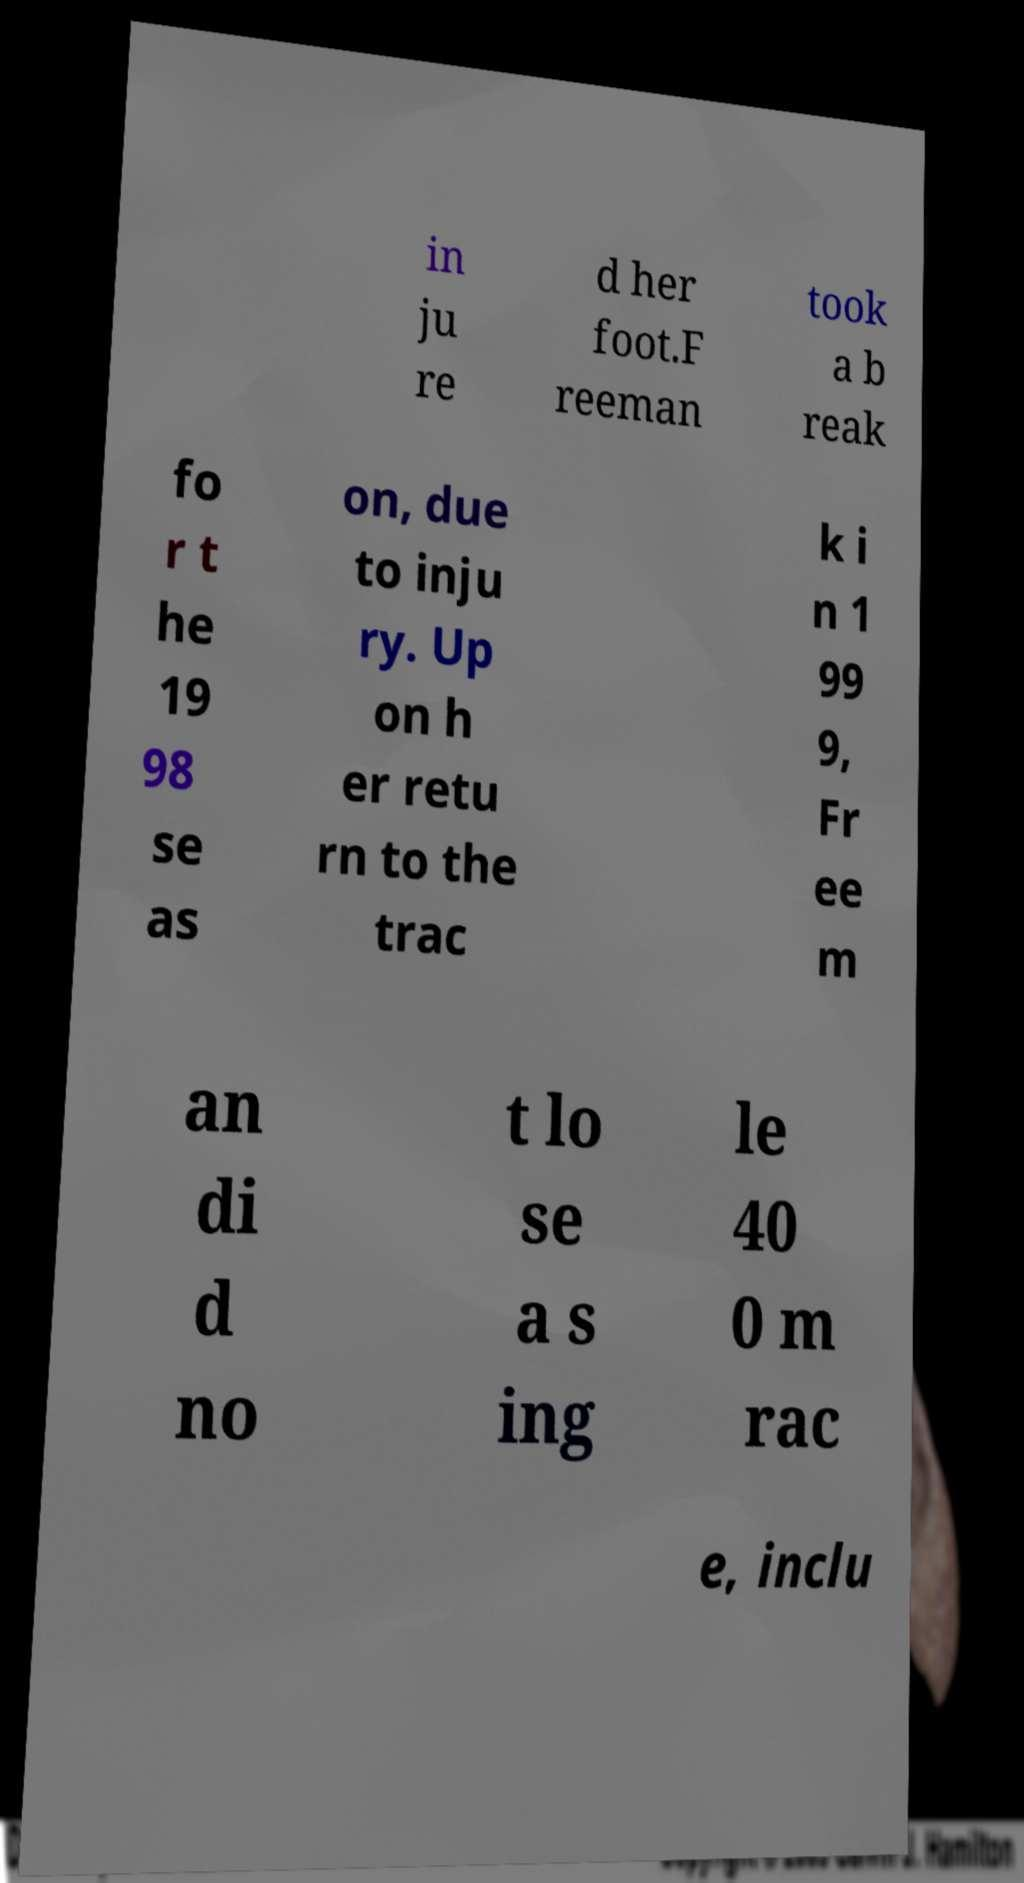Could you assist in decoding the text presented in this image and type it out clearly? in ju re d her foot.F reeman took a b reak fo r t he 19 98 se as on, due to inju ry. Up on h er retu rn to the trac k i n 1 99 9, Fr ee m an di d no t lo se a s ing le 40 0 m rac e, inclu 